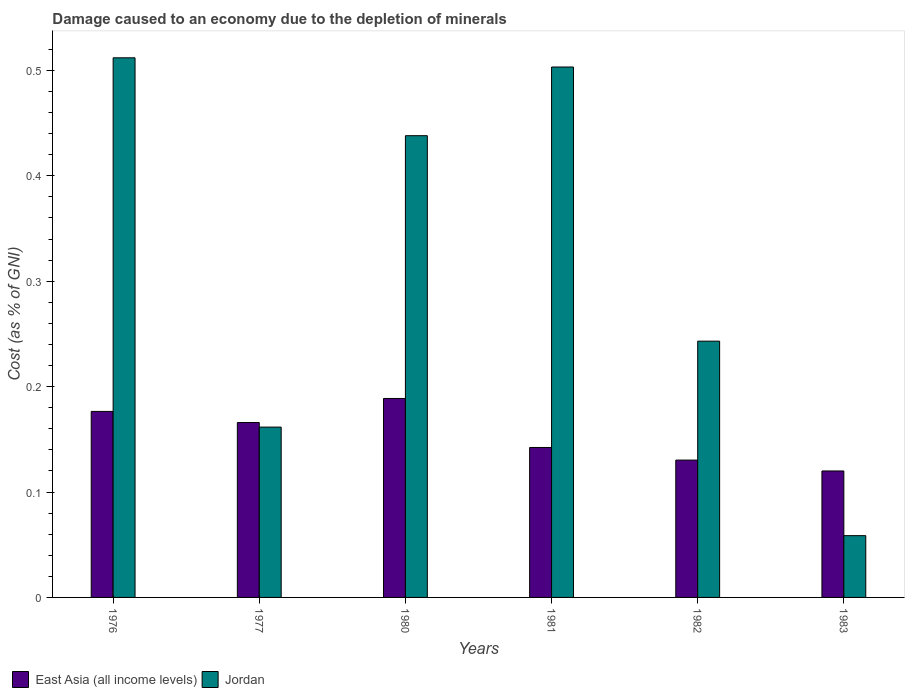How many different coloured bars are there?
Your answer should be very brief. 2. How many groups of bars are there?
Your answer should be very brief. 6. Are the number of bars per tick equal to the number of legend labels?
Give a very brief answer. Yes. How many bars are there on the 3rd tick from the right?
Your answer should be compact. 2. What is the label of the 4th group of bars from the left?
Make the answer very short. 1981. In how many cases, is the number of bars for a given year not equal to the number of legend labels?
Provide a succinct answer. 0. What is the cost of damage caused due to the depletion of minerals in Jordan in 1976?
Ensure brevity in your answer.  0.51. Across all years, what is the maximum cost of damage caused due to the depletion of minerals in Jordan?
Provide a succinct answer. 0.51. Across all years, what is the minimum cost of damage caused due to the depletion of minerals in East Asia (all income levels)?
Provide a succinct answer. 0.12. In which year was the cost of damage caused due to the depletion of minerals in Jordan maximum?
Ensure brevity in your answer.  1976. What is the total cost of damage caused due to the depletion of minerals in Jordan in the graph?
Offer a very short reply. 1.92. What is the difference between the cost of damage caused due to the depletion of minerals in East Asia (all income levels) in 1980 and that in 1983?
Make the answer very short. 0.07. What is the difference between the cost of damage caused due to the depletion of minerals in East Asia (all income levels) in 1981 and the cost of damage caused due to the depletion of minerals in Jordan in 1983?
Ensure brevity in your answer.  0.08. What is the average cost of damage caused due to the depletion of minerals in Jordan per year?
Your response must be concise. 0.32. In the year 1983, what is the difference between the cost of damage caused due to the depletion of minerals in East Asia (all income levels) and cost of damage caused due to the depletion of minerals in Jordan?
Your answer should be compact. 0.06. What is the ratio of the cost of damage caused due to the depletion of minerals in Jordan in 1981 to that in 1983?
Offer a very short reply. 8.59. Is the difference between the cost of damage caused due to the depletion of minerals in East Asia (all income levels) in 1977 and 1981 greater than the difference between the cost of damage caused due to the depletion of minerals in Jordan in 1977 and 1981?
Offer a terse response. Yes. What is the difference between the highest and the second highest cost of damage caused due to the depletion of minerals in East Asia (all income levels)?
Provide a succinct answer. 0.01. What is the difference between the highest and the lowest cost of damage caused due to the depletion of minerals in East Asia (all income levels)?
Give a very brief answer. 0.07. In how many years, is the cost of damage caused due to the depletion of minerals in East Asia (all income levels) greater than the average cost of damage caused due to the depletion of minerals in East Asia (all income levels) taken over all years?
Your response must be concise. 3. What does the 1st bar from the left in 1982 represents?
Your answer should be compact. East Asia (all income levels). What does the 2nd bar from the right in 1983 represents?
Offer a very short reply. East Asia (all income levels). How many bars are there?
Your answer should be very brief. 12. How many years are there in the graph?
Your answer should be compact. 6. What is the difference between two consecutive major ticks on the Y-axis?
Your response must be concise. 0.1. Does the graph contain any zero values?
Make the answer very short. No. Where does the legend appear in the graph?
Give a very brief answer. Bottom left. How many legend labels are there?
Offer a terse response. 2. How are the legend labels stacked?
Give a very brief answer. Horizontal. What is the title of the graph?
Ensure brevity in your answer.  Damage caused to an economy due to the depletion of minerals. Does "Guatemala" appear as one of the legend labels in the graph?
Keep it short and to the point. No. What is the label or title of the X-axis?
Offer a terse response. Years. What is the label or title of the Y-axis?
Your response must be concise. Cost (as % of GNI). What is the Cost (as % of GNI) of East Asia (all income levels) in 1976?
Keep it short and to the point. 0.18. What is the Cost (as % of GNI) of Jordan in 1976?
Keep it short and to the point. 0.51. What is the Cost (as % of GNI) of East Asia (all income levels) in 1977?
Keep it short and to the point. 0.17. What is the Cost (as % of GNI) of Jordan in 1977?
Your answer should be compact. 0.16. What is the Cost (as % of GNI) of East Asia (all income levels) in 1980?
Your answer should be compact. 0.19. What is the Cost (as % of GNI) in Jordan in 1980?
Keep it short and to the point. 0.44. What is the Cost (as % of GNI) of East Asia (all income levels) in 1981?
Provide a short and direct response. 0.14. What is the Cost (as % of GNI) of Jordan in 1981?
Make the answer very short. 0.5. What is the Cost (as % of GNI) in East Asia (all income levels) in 1982?
Ensure brevity in your answer.  0.13. What is the Cost (as % of GNI) in Jordan in 1982?
Keep it short and to the point. 0.24. What is the Cost (as % of GNI) of East Asia (all income levels) in 1983?
Make the answer very short. 0.12. What is the Cost (as % of GNI) in Jordan in 1983?
Give a very brief answer. 0.06. Across all years, what is the maximum Cost (as % of GNI) in East Asia (all income levels)?
Your answer should be very brief. 0.19. Across all years, what is the maximum Cost (as % of GNI) in Jordan?
Offer a very short reply. 0.51. Across all years, what is the minimum Cost (as % of GNI) of East Asia (all income levels)?
Your response must be concise. 0.12. Across all years, what is the minimum Cost (as % of GNI) of Jordan?
Provide a succinct answer. 0.06. What is the total Cost (as % of GNI) in East Asia (all income levels) in the graph?
Make the answer very short. 0.92. What is the total Cost (as % of GNI) in Jordan in the graph?
Your response must be concise. 1.92. What is the difference between the Cost (as % of GNI) in East Asia (all income levels) in 1976 and that in 1977?
Your answer should be compact. 0.01. What is the difference between the Cost (as % of GNI) in Jordan in 1976 and that in 1977?
Offer a terse response. 0.35. What is the difference between the Cost (as % of GNI) of East Asia (all income levels) in 1976 and that in 1980?
Your answer should be very brief. -0.01. What is the difference between the Cost (as % of GNI) in Jordan in 1976 and that in 1980?
Provide a succinct answer. 0.07. What is the difference between the Cost (as % of GNI) of East Asia (all income levels) in 1976 and that in 1981?
Offer a terse response. 0.03. What is the difference between the Cost (as % of GNI) in Jordan in 1976 and that in 1981?
Offer a terse response. 0.01. What is the difference between the Cost (as % of GNI) of East Asia (all income levels) in 1976 and that in 1982?
Your answer should be very brief. 0.05. What is the difference between the Cost (as % of GNI) of Jordan in 1976 and that in 1982?
Offer a terse response. 0.27. What is the difference between the Cost (as % of GNI) in East Asia (all income levels) in 1976 and that in 1983?
Give a very brief answer. 0.06. What is the difference between the Cost (as % of GNI) of Jordan in 1976 and that in 1983?
Provide a short and direct response. 0.45. What is the difference between the Cost (as % of GNI) of East Asia (all income levels) in 1977 and that in 1980?
Your answer should be very brief. -0.02. What is the difference between the Cost (as % of GNI) of Jordan in 1977 and that in 1980?
Provide a short and direct response. -0.28. What is the difference between the Cost (as % of GNI) of East Asia (all income levels) in 1977 and that in 1981?
Provide a short and direct response. 0.02. What is the difference between the Cost (as % of GNI) of Jordan in 1977 and that in 1981?
Provide a short and direct response. -0.34. What is the difference between the Cost (as % of GNI) in East Asia (all income levels) in 1977 and that in 1982?
Give a very brief answer. 0.04. What is the difference between the Cost (as % of GNI) in Jordan in 1977 and that in 1982?
Provide a succinct answer. -0.08. What is the difference between the Cost (as % of GNI) in East Asia (all income levels) in 1977 and that in 1983?
Provide a short and direct response. 0.05. What is the difference between the Cost (as % of GNI) in Jordan in 1977 and that in 1983?
Offer a very short reply. 0.1. What is the difference between the Cost (as % of GNI) in East Asia (all income levels) in 1980 and that in 1981?
Make the answer very short. 0.05. What is the difference between the Cost (as % of GNI) in Jordan in 1980 and that in 1981?
Ensure brevity in your answer.  -0.07. What is the difference between the Cost (as % of GNI) of East Asia (all income levels) in 1980 and that in 1982?
Your answer should be compact. 0.06. What is the difference between the Cost (as % of GNI) in Jordan in 1980 and that in 1982?
Your answer should be very brief. 0.2. What is the difference between the Cost (as % of GNI) in East Asia (all income levels) in 1980 and that in 1983?
Provide a short and direct response. 0.07. What is the difference between the Cost (as % of GNI) of Jordan in 1980 and that in 1983?
Keep it short and to the point. 0.38. What is the difference between the Cost (as % of GNI) in East Asia (all income levels) in 1981 and that in 1982?
Provide a short and direct response. 0.01. What is the difference between the Cost (as % of GNI) of Jordan in 1981 and that in 1982?
Your response must be concise. 0.26. What is the difference between the Cost (as % of GNI) of East Asia (all income levels) in 1981 and that in 1983?
Your answer should be very brief. 0.02. What is the difference between the Cost (as % of GNI) in Jordan in 1981 and that in 1983?
Your answer should be compact. 0.44. What is the difference between the Cost (as % of GNI) in East Asia (all income levels) in 1982 and that in 1983?
Provide a succinct answer. 0.01. What is the difference between the Cost (as % of GNI) of Jordan in 1982 and that in 1983?
Make the answer very short. 0.18. What is the difference between the Cost (as % of GNI) in East Asia (all income levels) in 1976 and the Cost (as % of GNI) in Jordan in 1977?
Give a very brief answer. 0.01. What is the difference between the Cost (as % of GNI) in East Asia (all income levels) in 1976 and the Cost (as % of GNI) in Jordan in 1980?
Keep it short and to the point. -0.26. What is the difference between the Cost (as % of GNI) of East Asia (all income levels) in 1976 and the Cost (as % of GNI) of Jordan in 1981?
Provide a succinct answer. -0.33. What is the difference between the Cost (as % of GNI) in East Asia (all income levels) in 1976 and the Cost (as % of GNI) in Jordan in 1982?
Offer a terse response. -0.07. What is the difference between the Cost (as % of GNI) of East Asia (all income levels) in 1976 and the Cost (as % of GNI) of Jordan in 1983?
Make the answer very short. 0.12. What is the difference between the Cost (as % of GNI) of East Asia (all income levels) in 1977 and the Cost (as % of GNI) of Jordan in 1980?
Your response must be concise. -0.27. What is the difference between the Cost (as % of GNI) of East Asia (all income levels) in 1977 and the Cost (as % of GNI) of Jordan in 1981?
Provide a short and direct response. -0.34. What is the difference between the Cost (as % of GNI) in East Asia (all income levels) in 1977 and the Cost (as % of GNI) in Jordan in 1982?
Offer a very short reply. -0.08. What is the difference between the Cost (as % of GNI) in East Asia (all income levels) in 1977 and the Cost (as % of GNI) in Jordan in 1983?
Your answer should be very brief. 0.11. What is the difference between the Cost (as % of GNI) in East Asia (all income levels) in 1980 and the Cost (as % of GNI) in Jordan in 1981?
Provide a short and direct response. -0.31. What is the difference between the Cost (as % of GNI) of East Asia (all income levels) in 1980 and the Cost (as % of GNI) of Jordan in 1982?
Keep it short and to the point. -0.05. What is the difference between the Cost (as % of GNI) in East Asia (all income levels) in 1980 and the Cost (as % of GNI) in Jordan in 1983?
Keep it short and to the point. 0.13. What is the difference between the Cost (as % of GNI) of East Asia (all income levels) in 1981 and the Cost (as % of GNI) of Jordan in 1982?
Keep it short and to the point. -0.1. What is the difference between the Cost (as % of GNI) of East Asia (all income levels) in 1981 and the Cost (as % of GNI) of Jordan in 1983?
Ensure brevity in your answer.  0.08. What is the difference between the Cost (as % of GNI) in East Asia (all income levels) in 1982 and the Cost (as % of GNI) in Jordan in 1983?
Provide a succinct answer. 0.07. What is the average Cost (as % of GNI) in East Asia (all income levels) per year?
Your response must be concise. 0.15. What is the average Cost (as % of GNI) in Jordan per year?
Give a very brief answer. 0.32. In the year 1976, what is the difference between the Cost (as % of GNI) in East Asia (all income levels) and Cost (as % of GNI) in Jordan?
Your answer should be very brief. -0.34. In the year 1977, what is the difference between the Cost (as % of GNI) in East Asia (all income levels) and Cost (as % of GNI) in Jordan?
Provide a succinct answer. 0. In the year 1980, what is the difference between the Cost (as % of GNI) of East Asia (all income levels) and Cost (as % of GNI) of Jordan?
Your answer should be compact. -0.25. In the year 1981, what is the difference between the Cost (as % of GNI) of East Asia (all income levels) and Cost (as % of GNI) of Jordan?
Provide a short and direct response. -0.36. In the year 1982, what is the difference between the Cost (as % of GNI) of East Asia (all income levels) and Cost (as % of GNI) of Jordan?
Keep it short and to the point. -0.11. In the year 1983, what is the difference between the Cost (as % of GNI) of East Asia (all income levels) and Cost (as % of GNI) of Jordan?
Your answer should be compact. 0.06. What is the ratio of the Cost (as % of GNI) in East Asia (all income levels) in 1976 to that in 1977?
Ensure brevity in your answer.  1.06. What is the ratio of the Cost (as % of GNI) in Jordan in 1976 to that in 1977?
Offer a terse response. 3.17. What is the ratio of the Cost (as % of GNI) in East Asia (all income levels) in 1976 to that in 1980?
Offer a very short reply. 0.94. What is the ratio of the Cost (as % of GNI) of Jordan in 1976 to that in 1980?
Keep it short and to the point. 1.17. What is the ratio of the Cost (as % of GNI) of East Asia (all income levels) in 1976 to that in 1981?
Give a very brief answer. 1.24. What is the ratio of the Cost (as % of GNI) in Jordan in 1976 to that in 1981?
Offer a very short reply. 1.02. What is the ratio of the Cost (as % of GNI) of East Asia (all income levels) in 1976 to that in 1982?
Offer a terse response. 1.35. What is the ratio of the Cost (as % of GNI) in Jordan in 1976 to that in 1982?
Ensure brevity in your answer.  2.11. What is the ratio of the Cost (as % of GNI) in East Asia (all income levels) in 1976 to that in 1983?
Your answer should be compact. 1.47. What is the ratio of the Cost (as % of GNI) of Jordan in 1976 to that in 1983?
Offer a very short reply. 8.74. What is the ratio of the Cost (as % of GNI) of East Asia (all income levels) in 1977 to that in 1980?
Offer a terse response. 0.88. What is the ratio of the Cost (as % of GNI) in Jordan in 1977 to that in 1980?
Keep it short and to the point. 0.37. What is the ratio of the Cost (as % of GNI) of East Asia (all income levels) in 1977 to that in 1981?
Offer a very short reply. 1.17. What is the ratio of the Cost (as % of GNI) of Jordan in 1977 to that in 1981?
Keep it short and to the point. 0.32. What is the ratio of the Cost (as % of GNI) in East Asia (all income levels) in 1977 to that in 1982?
Provide a short and direct response. 1.27. What is the ratio of the Cost (as % of GNI) of Jordan in 1977 to that in 1982?
Offer a terse response. 0.66. What is the ratio of the Cost (as % of GNI) in East Asia (all income levels) in 1977 to that in 1983?
Make the answer very short. 1.38. What is the ratio of the Cost (as % of GNI) of Jordan in 1977 to that in 1983?
Offer a very short reply. 2.76. What is the ratio of the Cost (as % of GNI) in East Asia (all income levels) in 1980 to that in 1981?
Your answer should be very brief. 1.33. What is the ratio of the Cost (as % of GNI) of Jordan in 1980 to that in 1981?
Provide a short and direct response. 0.87. What is the ratio of the Cost (as % of GNI) of East Asia (all income levels) in 1980 to that in 1982?
Your response must be concise. 1.45. What is the ratio of the Cost (as % of GNI) in Jordan in 1980 to that in 1982?
Offer a very short reply. 1.8. What is the ratio of the Cost (as % of GNI) of East Asia (all income levels) in 1980 to that in 1983?
Your answer should be compact. 1.57. What is the ratio of the Cost (as % of GNI) of Jordan in 1980 to that in 1983?
Your answer should be very brief. 7.47. What is the ratio of the Cost (as % of GNI) of East Asia (all income levels) in 1981 to that in 1982?
Keep it short and to the point. 1.09. What is the ratio of the Cost (as % of GNI) of Jordan in 1981 to that in 1982?
Your response must be concise. 2.07. What is the ratio of the Cost (as % of GNI) in East Asia (all income levels) in 1981 to that in 1983?
Ensure brevity in your answer.  1.19. What is the ratio of the Cost (as % of GNI) in Jordan in 1981 to that in 1983?
Provide a short and direct response. 8.59. What is the ratio of the Cost (as % of GNI) in East Asia (all income levels) in 1982 to that in 1983?
Offer a very short reply. 1.09. What is the ratio of the Cost (as % of GNI) in Jordan in 1982 to that in 1983?
Provide a succinct answer. 4.15. What is the difference between the highest and the second highest Cost (as % of GNI) of East Asia (all income levels)?
Keep it short and to the point. 0.01. What is the difference between the highest and the second highest Cost (as % of GNI) of Jordan?
Offer a terse response. 0.01. What is the difference between the highest and the lowest Cost (as % of GNI) in East Asia (all income levels)?
Ensure brevity in your answer.  0.07. What is the difference between the highest and the lowest Cost (as % of GNI) in Jordan?
Offer a very short reply. 0.45. 